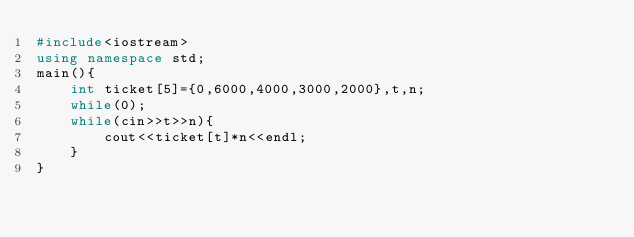Convert code to text. <code><loc_0><loc_0><loc_500><loc_500><_C++_>#include<iostream>
using namespace std;
main(){
	int ticket[5]={0,6000,4000,3000,2000},t,n;
	while(0);
	while(cin>>t>>n){
		cout<<ticket[t]*n<<endl;
	}
}</code> 